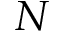Convert formula to latex. <formula><loc_0><loc_0><loc_500><loc_500>N</formula> 